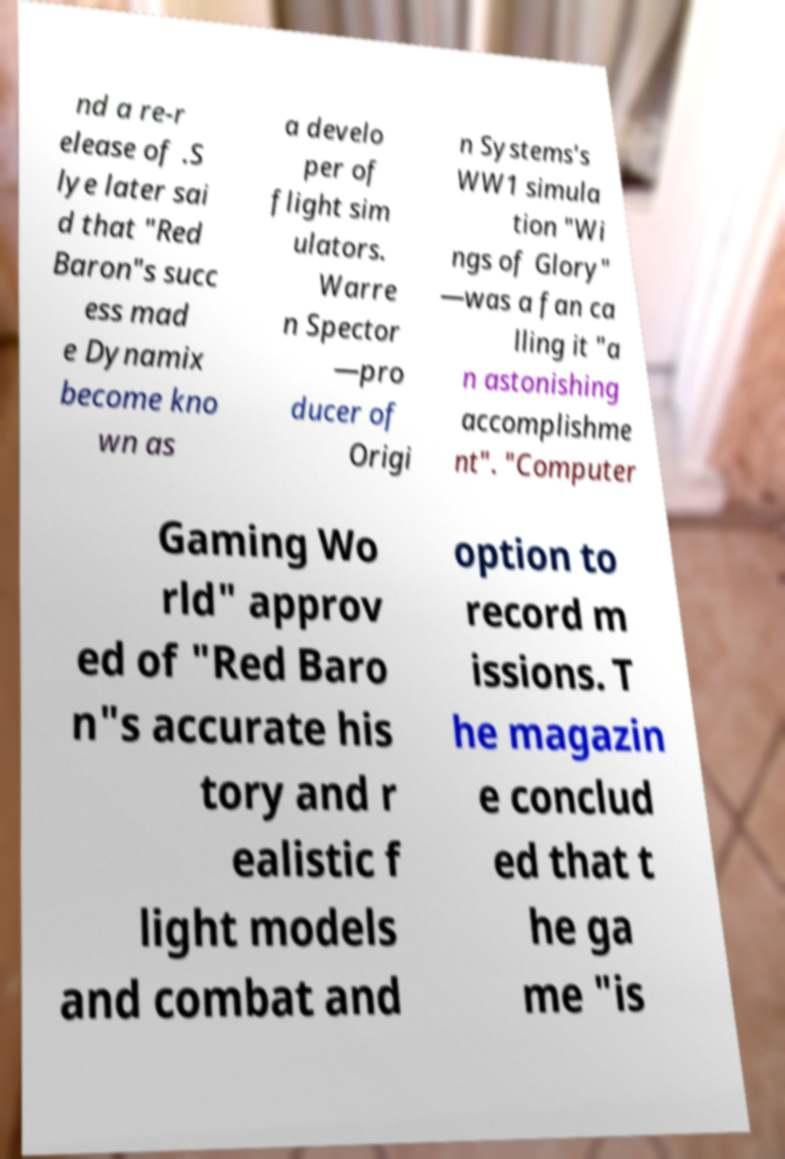Could you extract and type out the text from this image? nd a re-r elease of .S lye later sai d that "Red Baron"s succ ess mad e Dynamix become kno wn as a develo per of flight sim ulators. Warre n Spector —pro ducer of Origi n Systems's WW1 simula tion "Wi ngs of Glory" —was a fan ca lling it "a n astonishing accomplishme nt". "Computer Gaming Wo rld" approv ed of "Red Baro n"s accurate his tory and r ealistic f light models and combat and option to record m issions. T he magazin e conclud ed that t he ga me "is 